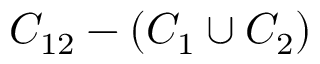<formula> <loc_0><loc_0><loc_500><loc_500>C _ { 1 2 } - ( C _ { 1 } \cup C _ { 2 } )</formula> 